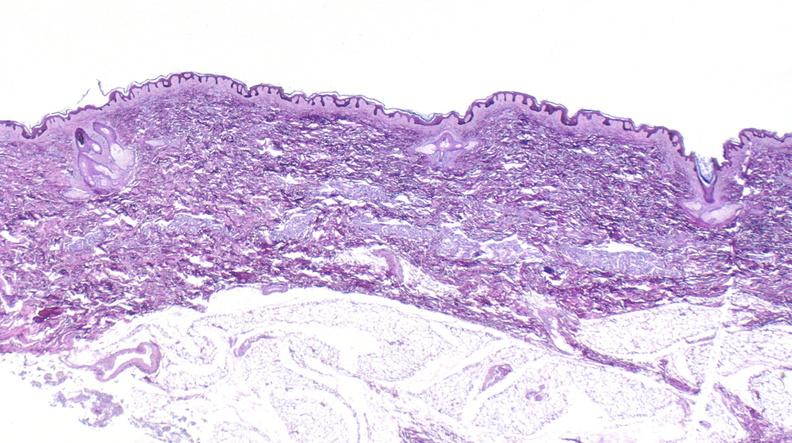does medulloblastoma show scleroderma?
Answer the question using a single word or phrase. No 